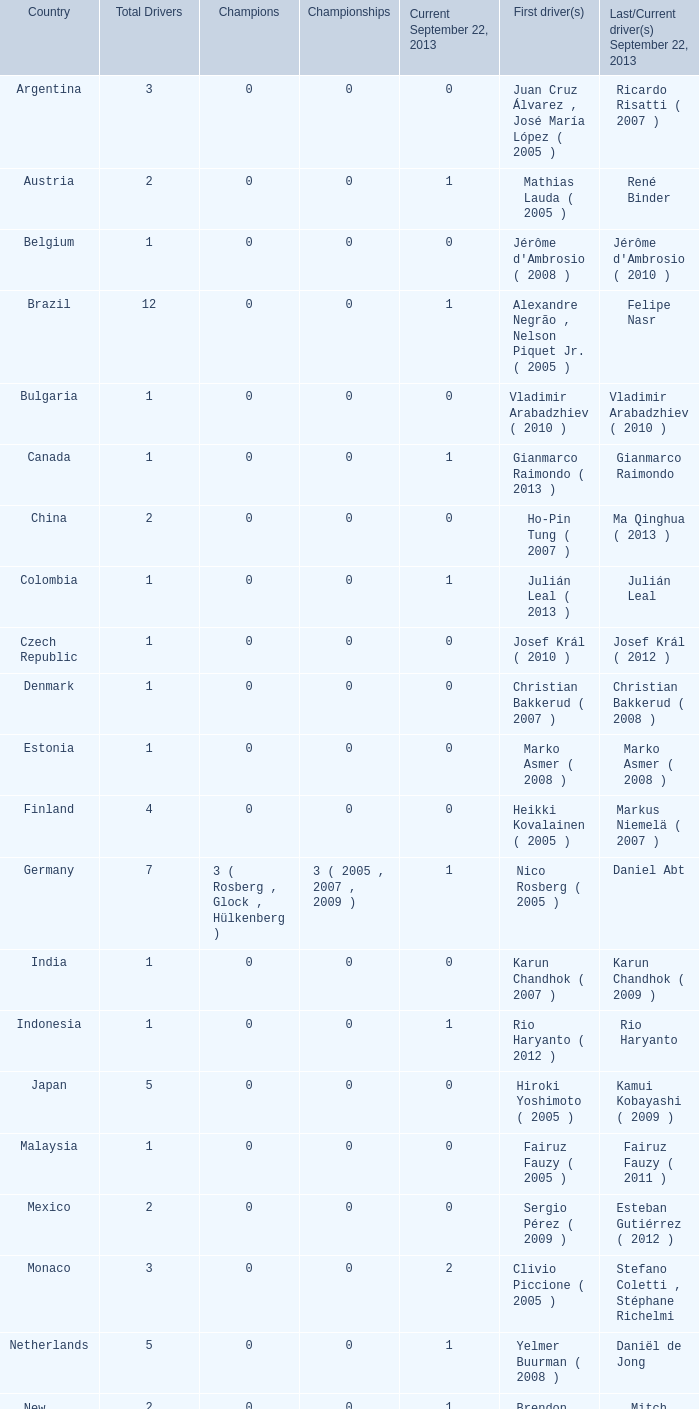How many champions were there when the first driver was hiroki yoshimoto ( 2005 )? 0.0. 